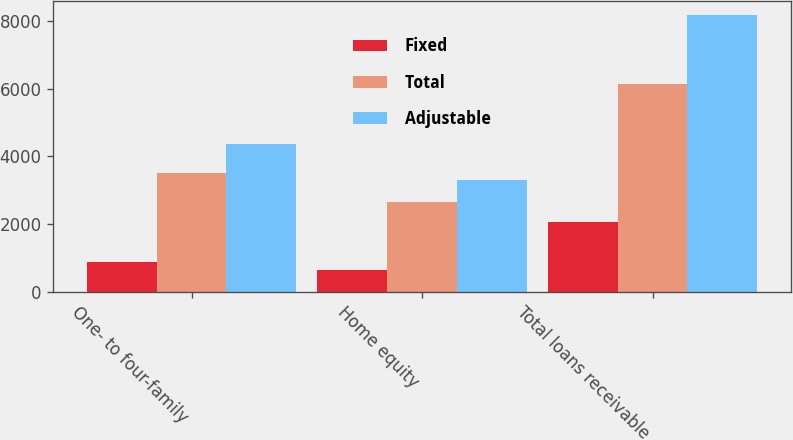Convert chart to OTSL. <chart><loc_0><loc_0><loc_500><loc_500><stacked_bar_chart><ecel><fcel>One- to four-family<fcel>Home equity<fcel>Total loans receivable<nl><fcel>Fixed<fcel>860.3<fcel>642.5<fcel>2048.5<nl><fcel>Total<fcel>3503.4<fcel>2647.1<fcel>6150.5<nl><fcel>Adjustable<fcel>4363.7<fcel>3289.6<fcel>8199<nl></chart> 